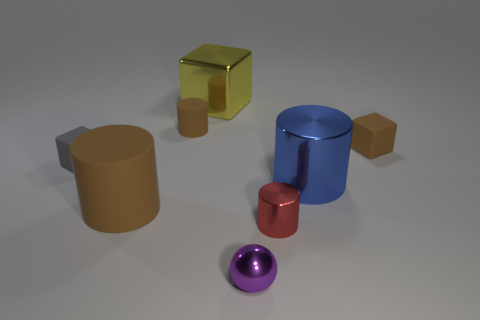There is a small block that is the same color as the large matte object; what is it made of?
Your response must be concise. Rubber. There is a cube that is in front of the big cube and on the left side of the tiny red metal object; what material is it made of?
Ensure brevity in your answer.  Rubber. There is a small cylinder behind the tiny brown cube; are there any tiny purple things behind it?
Provide a short and direct response. No. There is a metal object that is behind the tiny metal cylinder and to the left of the large blue metal cylinder; how big is it?
Your answer should be very brief. Large. What number of yellow objects are either small rubber things or cylinders?
Ensure brevity in your answer.  0. What is the shape of the red object that is the same size as the gray matte object?
Offer a very short reply. Cylinder. What number of other things are there of the same color as the small metal ball?
Provide a succinct answer. 0. What is the size of the brown cylinder that is behind the big cylinder behind the big brown matte cylinder?
Your response must be concise. Small. Is the material of the big thing right of the purple thing the same as the small purple object?
Your answer should be very brief. Yes. There is a large object that is behind the large shiny cylinder; what is its shape?
Make the answer very short. Cube. 